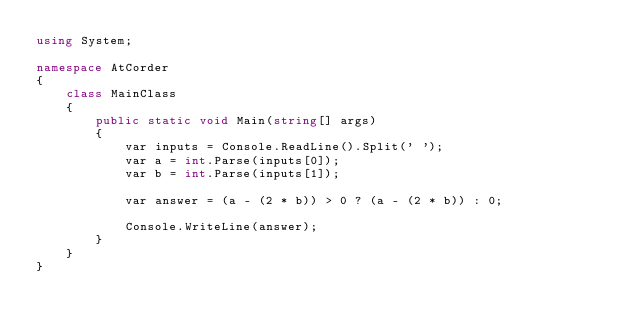<code> <loc_0><loc_0><loc_500><loc_500><_C#_>using System;

namespace AtCorder
{
    class MainClass
    {
        public static void Main(string[] args)
        {
            var inputs = Console.ReadLine().Split(' ');
            var a = int.Parse(inputs[0]);
            var b = int.Parse(inputs[1]);

            var answer = (a - (2 * b)) > 0 ? (a - (2 * b)) : 0;

            Console.WriteLine(answer);
        }
    }
}
</code> 